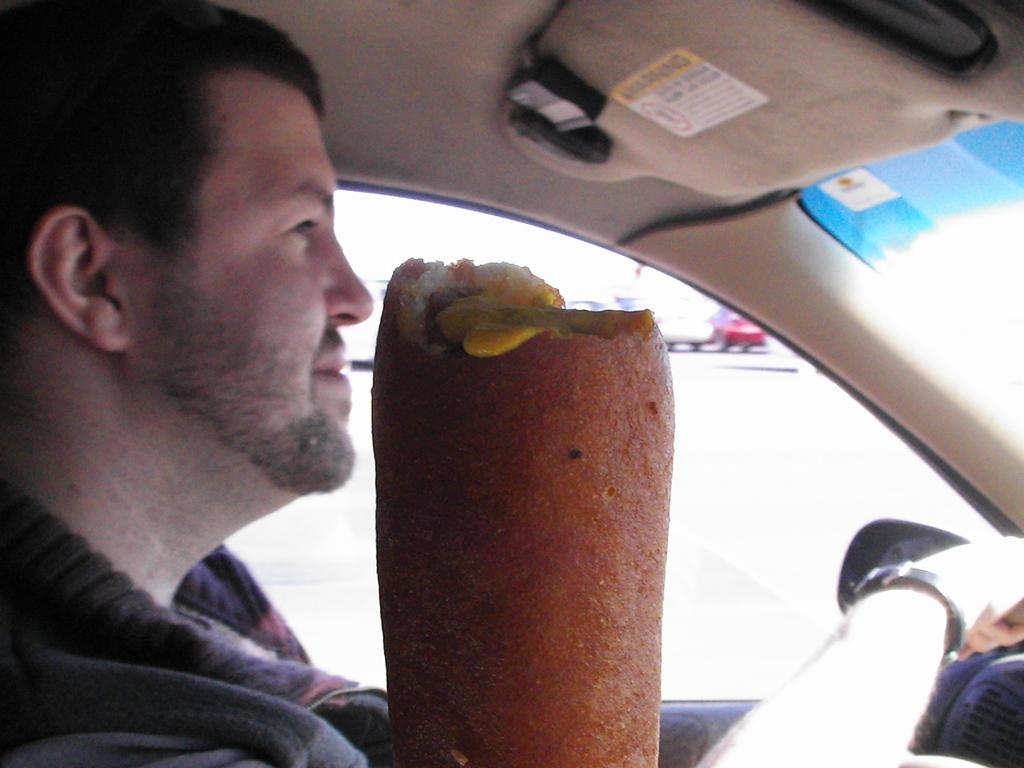What is the person in the image doing? There is a person sitting in the car. What is located in front of the car? There is food in front of the car. Can you describe the color of the food? The food is brown in color. What else can be seen in the background of the image? There are other vehicles visible in the background. What type of furniture is being discussed in the story depicted in the image? There is no story or furniture present in the image; it features a person sitting in a car with food in front of it and other vehicles in the background. 